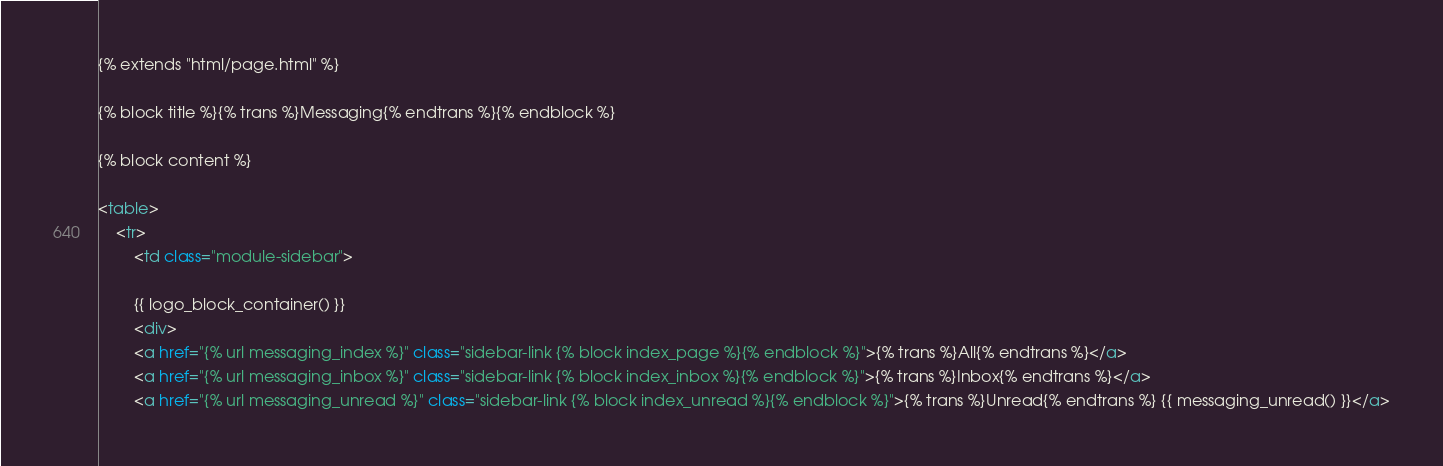<code> <loc_0><loc_0><loc_500><loc_500><_HTML_>{% extends "html/page.html" %}

{% block title %}{% trans %}Messaging{% endtrans %}{% endblock %}

{% block content %}

<table>
    <tr>
        <td class="module-sidebar">
        
		{{ logo_block_container() }}
		<div>
		<a href="{% url messaging_index %}" class="sidebar-link {% block index_page %}{% endblock %}">{% trans %}All{% endtrans %}</a>
        <a href="{% url messaging_inbox %}" class="sidebar-link {% block index_inbox %}{% endblock %}">{% trans %}Inbox{% endtrans %}</a>
        <a href="{% url messaging_unread %}" class="sidebar-link {% block index_unread %}{% endblock %}">{% trans %}Unread{% endtrans %} {{ messaging_unread() }}</a></code> 